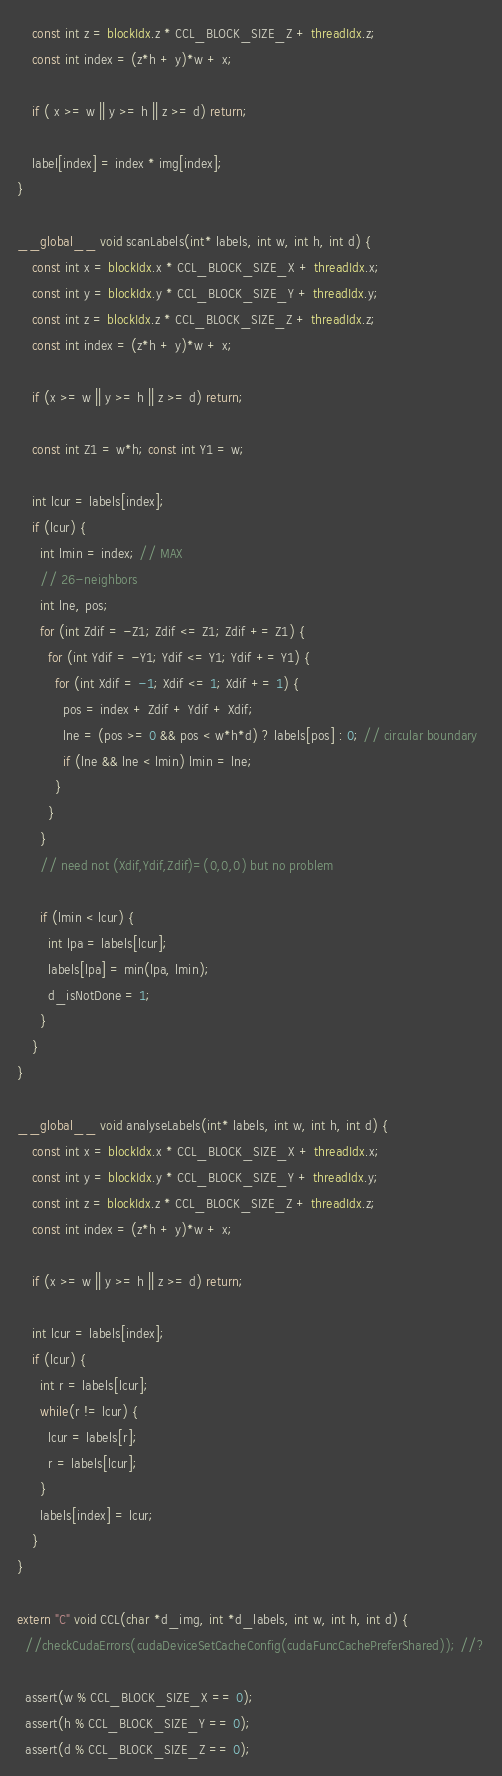<code> <loc_0><loc_0><loc_500><loc_500><_Cuda_>    const int z = blockIdx.z * CCL_BLOCK_SIZE_Z + threadIdx.z;
    const int index = (z*h + y)*w + x;

    if ( x >= w || y >= h || z >= d) return;

    label[index] = index * img[index];
}

__global__ void scanLabels(int* labels, int w, int h, int d) {
    const int x = blockIdx.x * CCL_BLOCK_SIZE_X + threadIdx.x;
    const int y = blockIdx.y * CCL_BLOCK_SIZE_Y + threadIdx.y;
    const int z = blockIdx.z * CCL_BLOCK_SIZE_Z + threadIdx.z;
    const int index = (z*h + y)*w + x;

    if (x >= w || y >= h || z >= d) return;

    const int Z1 = w*h; const int Y1 = w;

    int lcur = labels[index];
    if (lcur) {
      int lmin = index; // MAX
      // 26-neighbors
      int lne, pos;
      for (int Zdif = -Z1; Zdif <= Z1; Zdif += Z1) {
        for (int Ydif = -Y1; Ydif <= Y1; Ydif += Y1) {
          for (int Xdif = -1; Xdif <= 1; Xdif += 1) {
            pos = index + Zdif + Ydif + Xdif;
            lne = (pos >= 0 && pos < w*h*d) ? labels[pos] : 0; // circular boundary
            if (lne && lne < lmin) lmin = lne;
          }
        }
      }
      // need not (Xdif,Ydif,Zdif)=(0,0,0) but no problem

      if (lmin < lcur) {
        int lpa = labels[lcur];
        labels[lpa] = min(lpa, lmin);
        d_isNotDone = 1;
      }
    }
}

__global__ void analyseLabels(int* labels, int w, int h, int d) {
    const int x = blockIdx.x * CCL_BLOCK_SIZE_X + threadIdx.x;
    const int y = blockIdx.y * CCL_BLOCK_SIZE_Y + threadIdx.y;
    const int z = blockIdx.z * CCL_BLOCK_SIZE_Z + threadIdx.z;
    const int index = (z*h + y)*w + x;

    if (x >= w || y >= h || z >= d) return;

    int lcur = labels[index];
    if (lcur) {
      int r = labels[lcur];
      while(r != lcur) {
        lcur = labels[r];
        r = labels[lcur];
      }
      labels[index] = lcur;
    }
}

extern "C" void CCL(char *d_img, int *d_labels, int w, int h, int d) {
  //checkCudaErrors(cudaDeviceSetCacheConfig(cudaFuncCachePreferShared)); //?

  assert(w % CCL_BLOCK_SIZE_X == 0);
  assert(h % CCL_BLOCK_SIZE_Y == 0);
  assert(d % CCL_BLOCK_SIZE_Z == 0);

</code> 